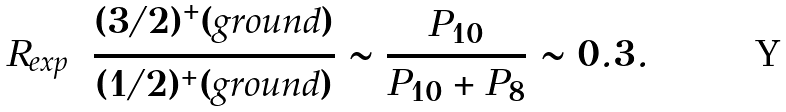<formula> <loc_0><loc_0><loc_500><loc_500>R _ { e x p } = \frac { ( 3 / 2 ) ^ { + } ( g r o u n d ) } { ( 1 / 2 ) ^ { + } ( g r o u n d ) } \sim \frac { P _ { 1 0 } } { P _ { 1 0 } + P _ { 8 } } \sim 0 . 3 .</formula> 